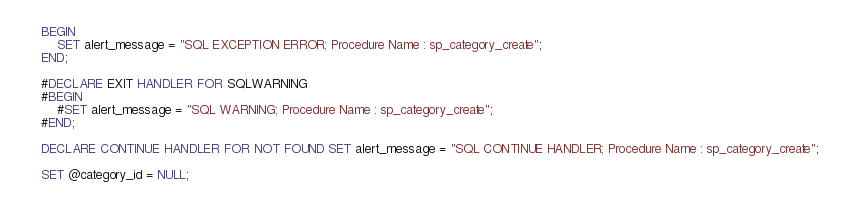Convert code to text. <code><loc_0><loc_0><loc_500><loc_500><_SQL_>	BEGIN
		SET alert_message = "SQL EXCEPTION ERROR; Procedure Name : sp_category_create";
	END;

	#DECLARE EXIT HANDLER FOR SQLWARNING
	#BEGIN
		#SET alert_message = "SQL WARNING; Procedure Name : sp_category_create";
	#END;

	DECLARE CONTINUE HANDLER FOR NOT FOUND SET alert_message = "SQL CONTINUE HANDLER; Procedure Name : sp_category_create";

	SET @category_id = NULL;
</code> 